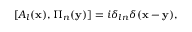Convert formula to latex. <formula><loc_0><loc_0><loc_500><loc_500>[ A _ { l } ( { x } ) , \Pi _ { n } ( { y } ) ] = i \delta _ { \ln } \delta ( { x - y } ) ,</formula> 